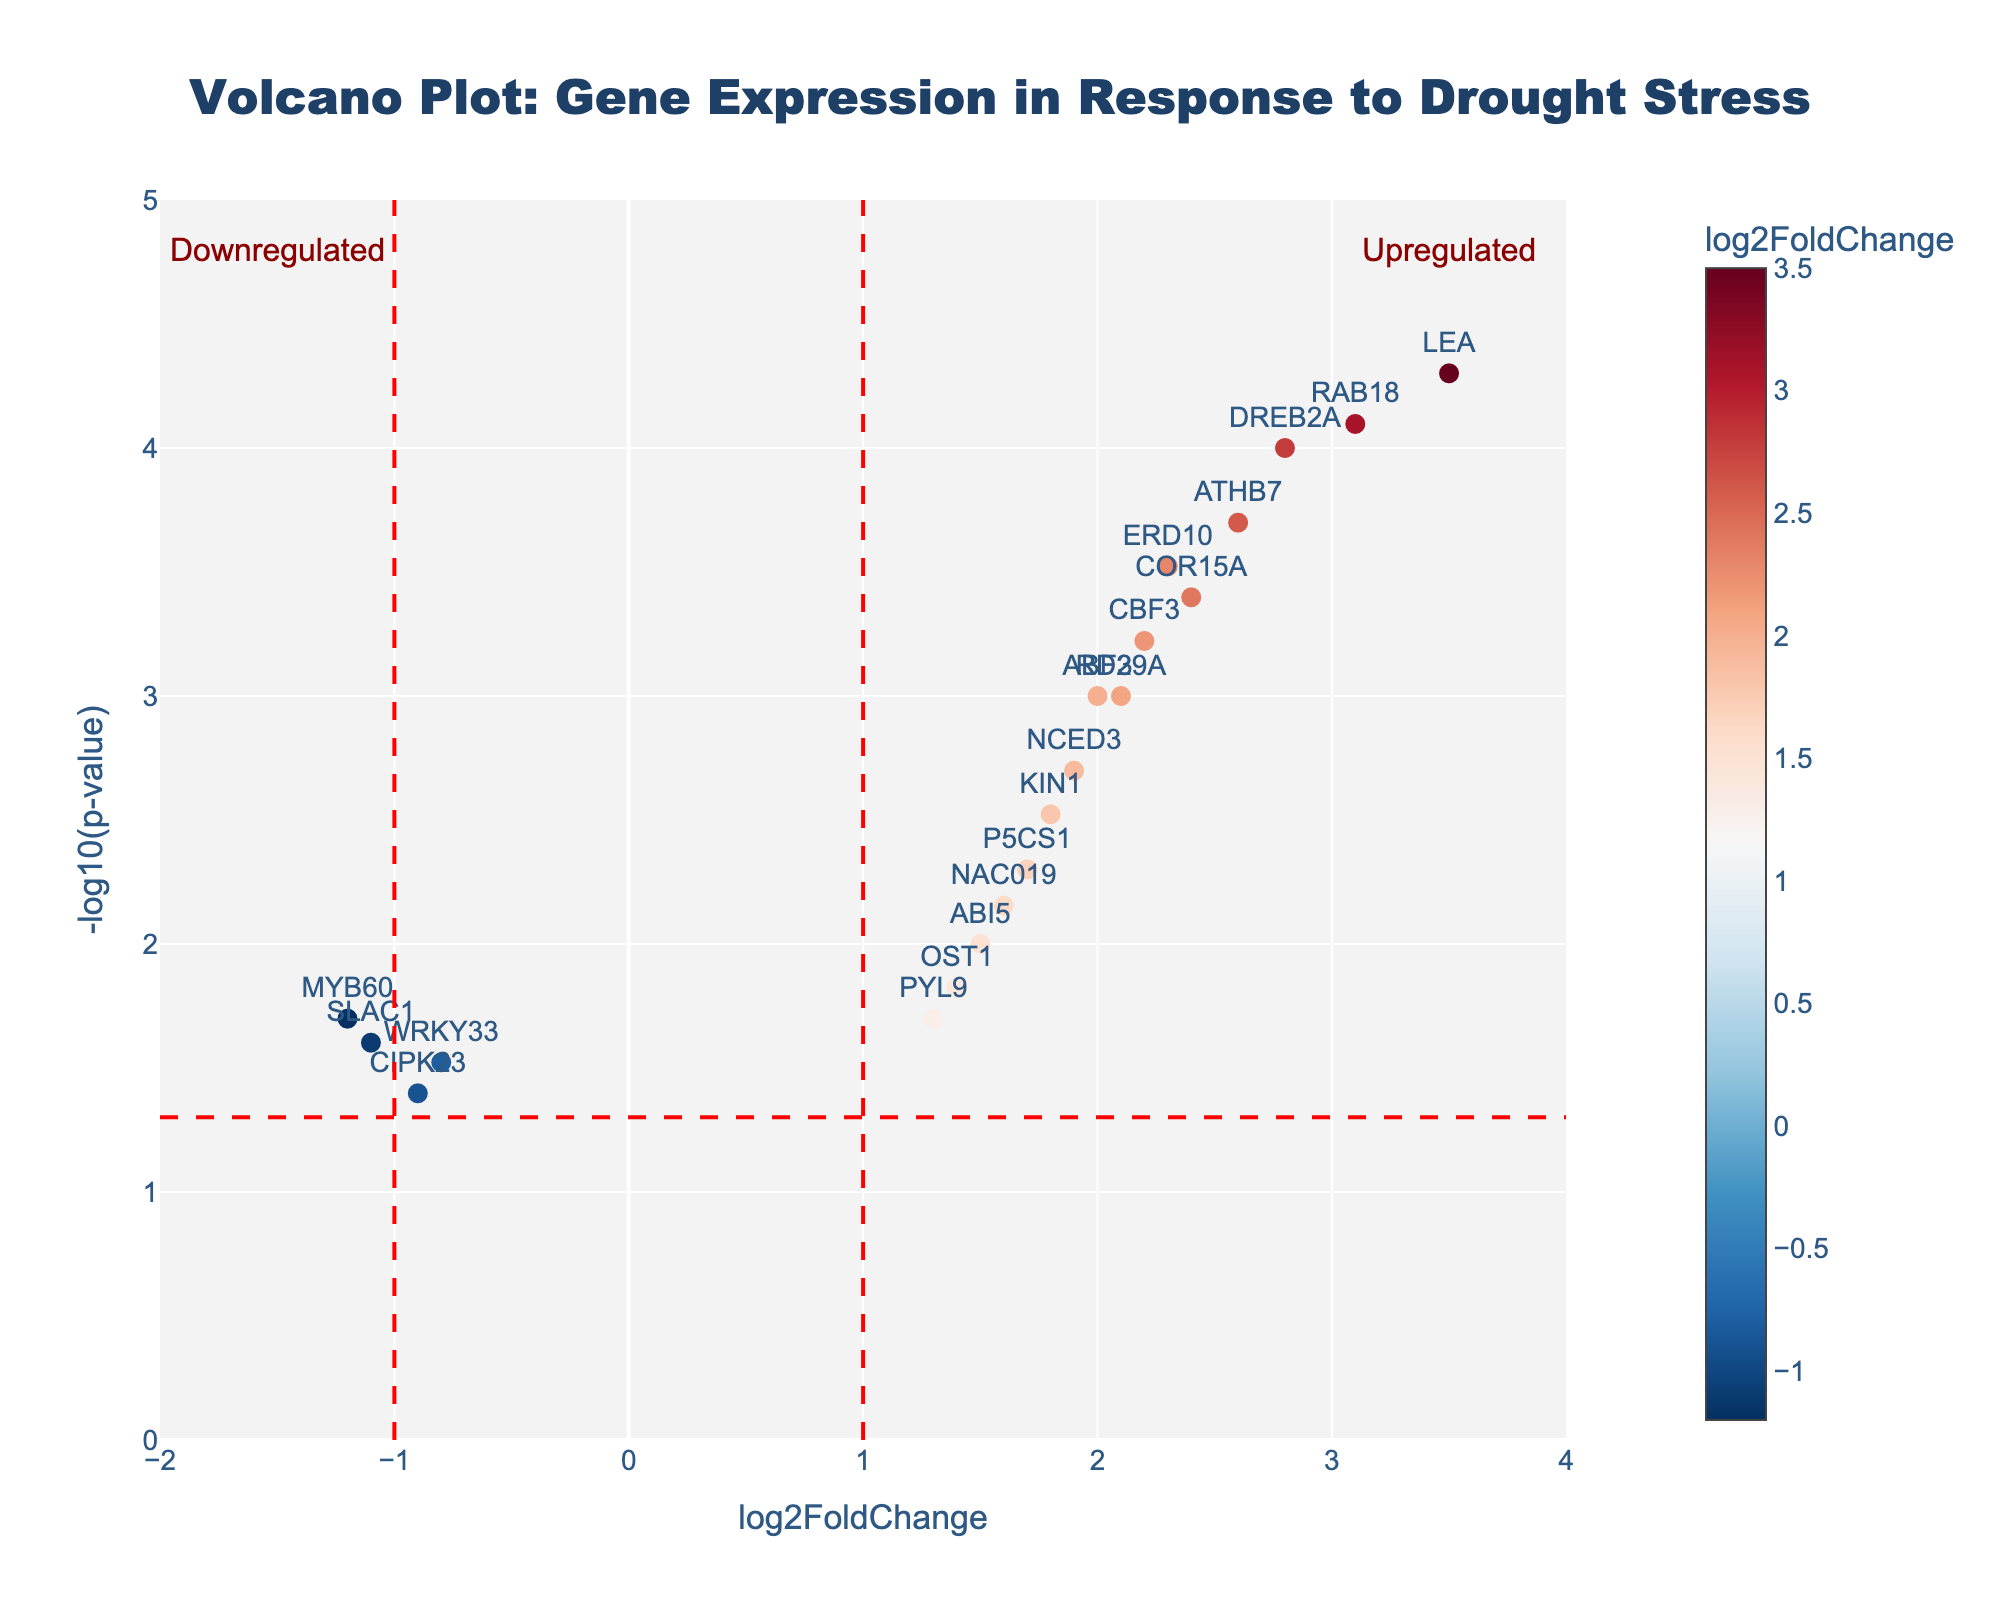What's the title of the plot? The title of the plot is at the top center. It reads "Volcano Plot: Gene Expression in Response to Drought Stress."
Answer: Volcano Plot: Gene Expression in Response to Drought Stress What do the x- and y-axes represent in this plot? The x-axis represents the log2FoldChange, showing how much gene expression has increased or decreased. The y-axis represents the -log10(p-value), indicating the significance of the change in gene expression.
Answer: log2FoldChange and -log10(p-value) How many genes are upregulated with log2FoldChange greater than 2? To find the number of upregulated genes, look for points to the right of the vertical red dashed line at log2FoldChange = 1 and above a value of 2 on the x-axis. There are 7 such genes: DREB2A, LEA, ATHB7, RD29A, ABF3, RAB18 and CBF3.
Answer: 7 Which gene has the highest log2FoldChange value and what is its p-value? The gene with the highest log2FoldChange can be determined by identifying the farthest point to the right on the x-axis. It is LEA with a log2FoldChange of 3.5 and a p-value of 0.00005.
Answer: LEA with p-value 0.00005 Compare the -log10(p-value) of genes DREB2A and MYB60. Which one is more significant and by how much? DREB2A has a -log10(p-value) of 4 and MYB60 has a -log10(p-value) of 1.70. To determine which is more significant and by how much, subtract the smaller value from the larger one: 4 - 1.70 = 2.30. Therefore, DREB2A is more significant by 2.30.
Answer: DREB2A, by 2.30 Which gene is closest to the thresholds lines and considered marginally significant? The thresholds lines for significance are drawn at -log10(p-value) = 1.30 and log2FoldChange = -1 and 1. The gene closest to this threshold and somewhat overlaps is PYL9 with log2FoldChange of 1.3 and p-value of 0.02.
Answer: PYL9 How many genes have been significantly downregulated (log2FoldChange < -1) and what are their names? Look for genes with log2FoldChange less than -1 and significant p-values (above the horizontal threshold line). There are two such genes: MYB60 and SLAC1.
Answer: 2 (MYB60, SLAC1) Identify the gene with the smallest p-value and its corresponding log2FoldChange. The smallest p-value can be found by locating the highest point on the y-axis. It is LEA with a p-value of 0.00005 and a log2FoldChange of 3.5.
Answer: LEA with log2FoldChange of 3.5 What is the difference in log2FoldChange between ATHB7 and CIPK23? Calculate the difference by subtracting the log2FoldChange of CIPK23 from ATHB7: 2.6 - (-0.9) = 2.6 + 0.9 = 3.5.
Answer: 3.5 Which region in the plot indicates upregulated genes, and how is it annotated? The region indicating upregulated genes is to the right of the vertical red dashed line at log2FoldChange = 1. It is annotated with the text "Upregulated" at the top right.
Answer: Top right, "Upregulated" 